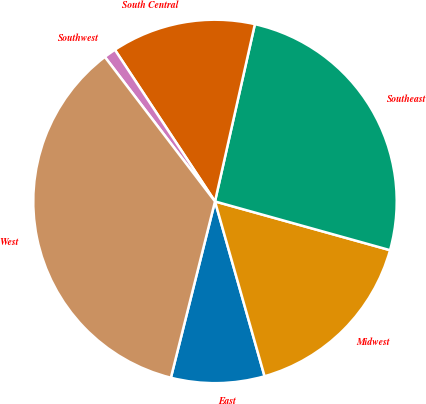<chart> <loc_0><loc_0><loc_500><loc_500><pie_chart><fcel>East<fcel>Midwest<fcel>Southeast<fcel>South Central<fcel>Southwest<fcel>West<nl><fcel>8.3%<fcel>16.28%<fcel>25.8%<fcel>12.81%<fcel>1.08%<fcel>35.73%<nl></chart> 